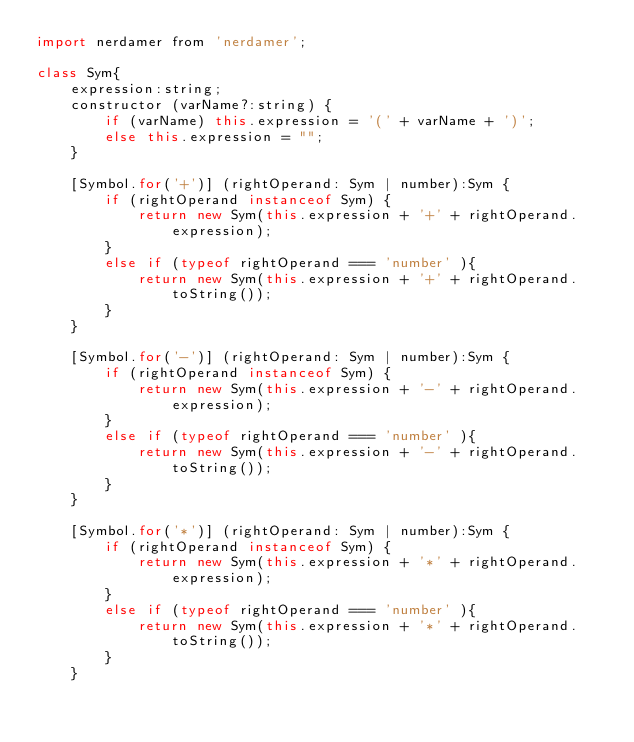Convert code to text. <code><loc_0><loc_0><loc_500><loc_500><_JavaScript_>import nerdamer from 'nerdamer';

class Sym{
    expression:string;
    constructor (varName?:string) {
        if (varName) this.expression = '(' + varName + ')';
        else this.expression = "";
    }

    [Symbol.for('+')] (rightOperand: Sym | number):Sym {
        if (rightOperand instanceof Sym) {
            return new Sym(this.expression + '+' + rightOperand.expression);
        }
        else if (typeof rightOperand === 'number' ){
            return new Sym(this.expression + '+' + rightOperand.toString());
        }
    }

    [Symbol.for('-')] (rightOperand: Sym | number):Sym {
        if (rightOperand instanceof Sym) {
            return new Sym(this.expression + '-' + rightOperand.expression);
        }
        else if (typeof rightOperand === 'number' ){
            return new Sym(this.expression + '-' + rightOperand.toString());
        }
    }

    [Symbol.for('*')] (rightOperand: Sym | number):Sym {
        if (rightOperand instanceof Sym) {
            return new Sym(this.expression + '*' + rightOperand.expression);
        }
        else if (typeof rightOperand === 'number' ){
            return new Sym(this.expression + '*' + rightOperand.toString());
        }
    }
</code> 